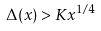<formula> <loc_0><loc_0><loc_500><loc_500>\Delta ( x ) > K x ^ { 1 / 4 }</formula> 